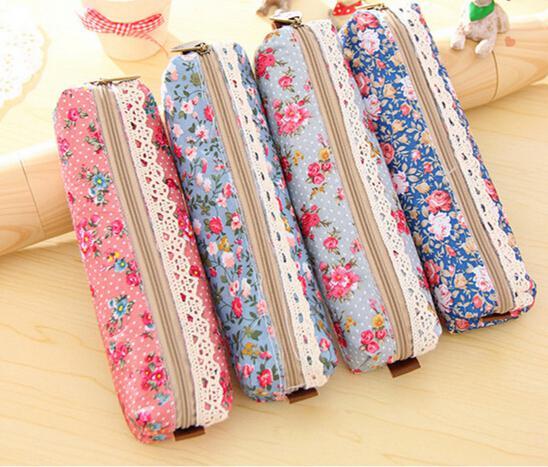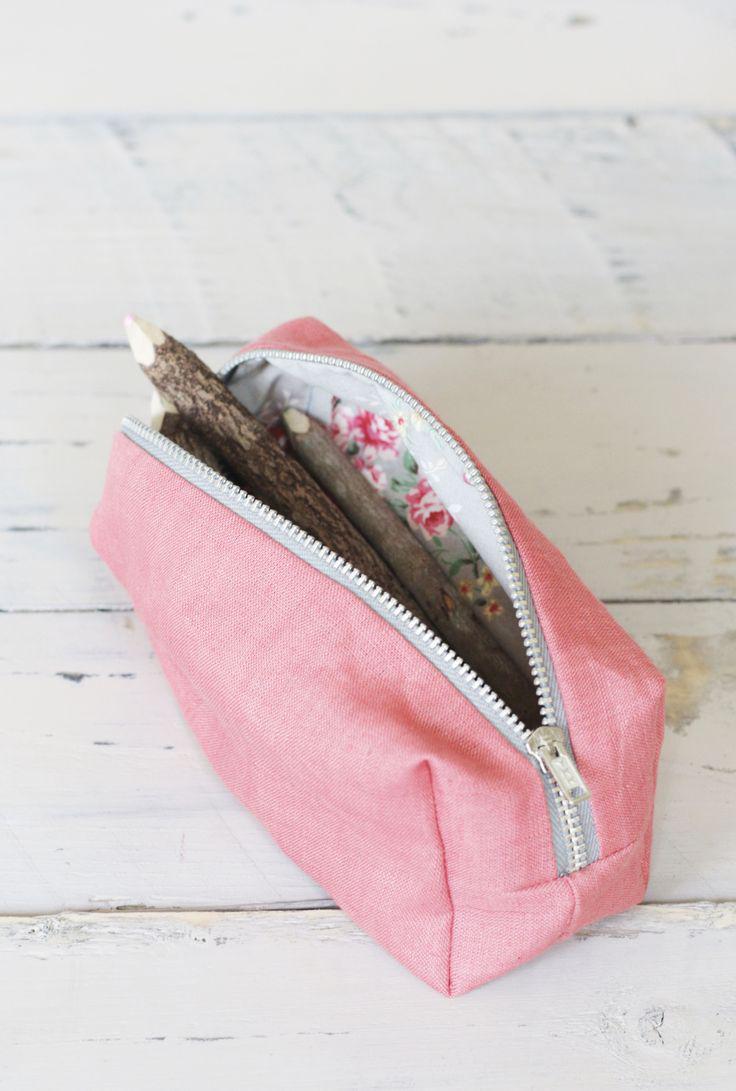The first image is the image on the left, the second image is the image on the right. Analyze the images presented: Is the assertion "The left image features a case with one zipper across the top, with a charm attached to the zipper pull, and an all-over print depicting cute animals, and the right image shows a mostly pink case closest to the camera." valid? Answer yes or no. No. 